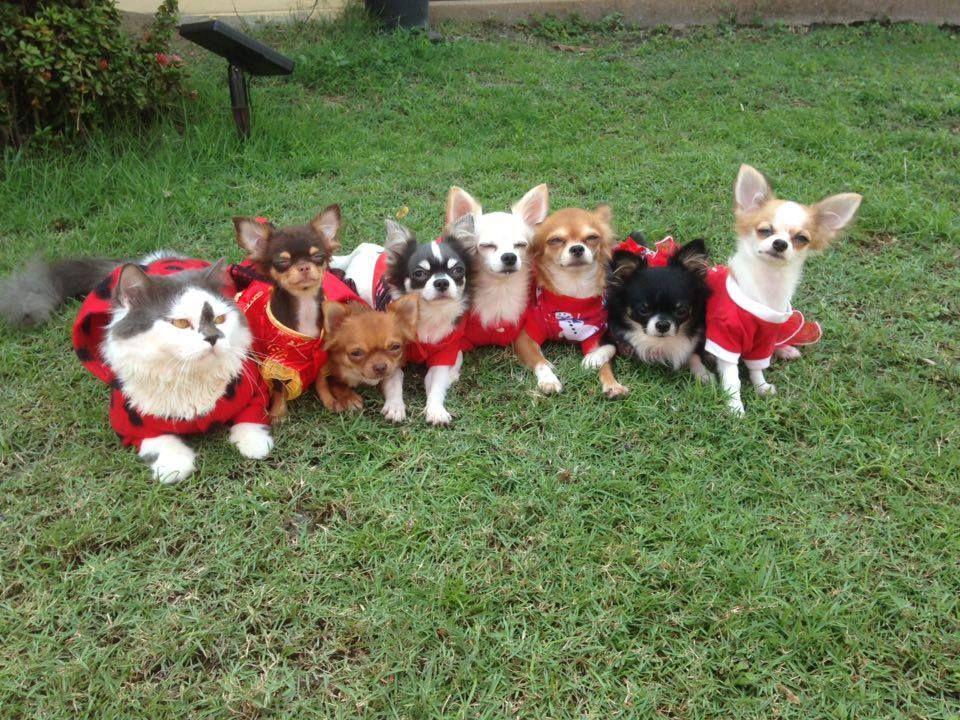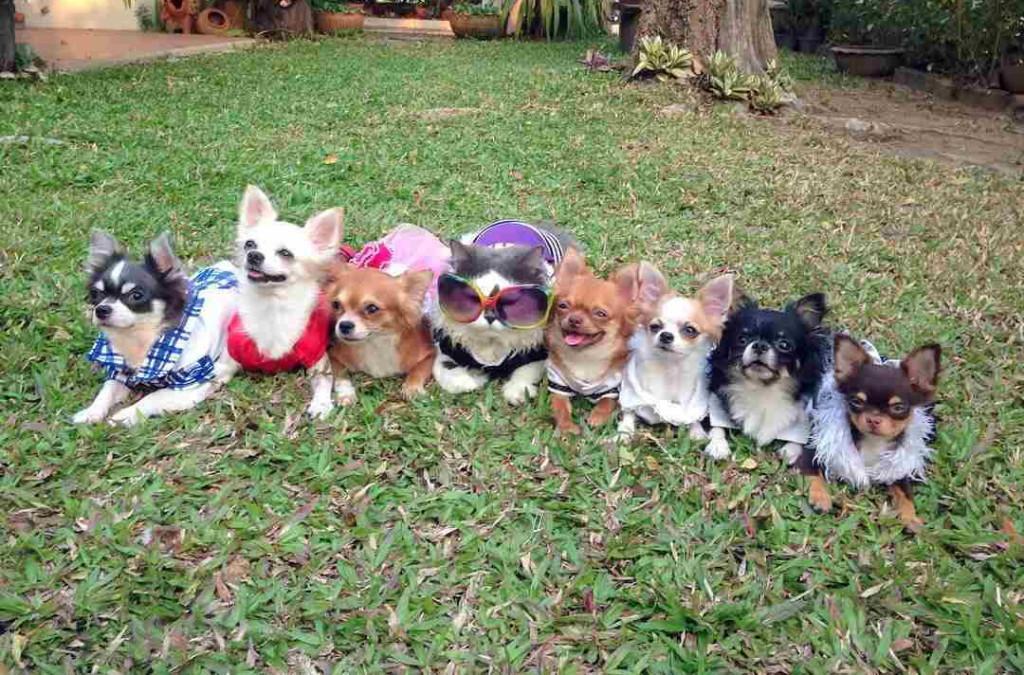The first image is the image on the left, the second image is the image on the right. Assess this claim about the two images: "At least one dog is wearing a red shirt.". Correct or not? Answer yes or no. Yes. The first image is the image on the left, the second image is the image on the right. Examine the images to the left and right. Is the description "In one image, chihuahuas are arranged in a horizontal line with a gray cat toward the middle of the row." accurate? Answer yes or no. Yes. 